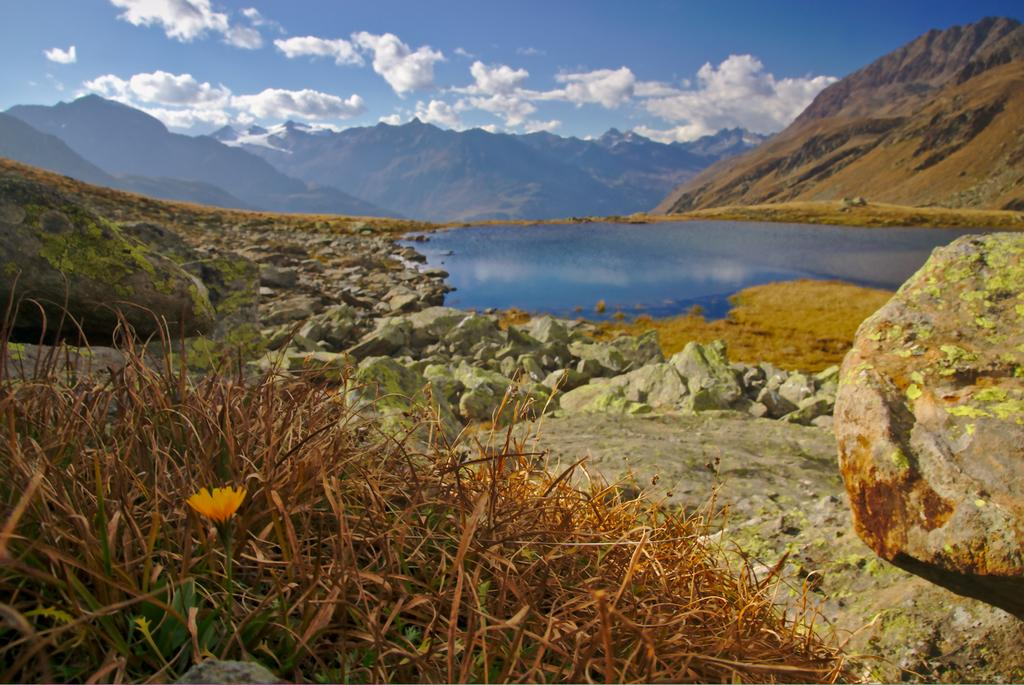What type of vegetation can be seen in the image? There is grass and flowers visible in the image. What other elements can be seen in the image? There are stones, water, mountains, and clouds in the sky in the image. What holiday is being celebrated in the image? There is no indication of a holiday being celebrated in the image. How does the class of flowers in the image compare to the class of flowers in another image? There is no other image provided for comparison, so we cannot make any comparisons. 